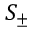<formula> <loc_0><loc_0><loc_500><loc_500>S _ { \pm }</formula> 